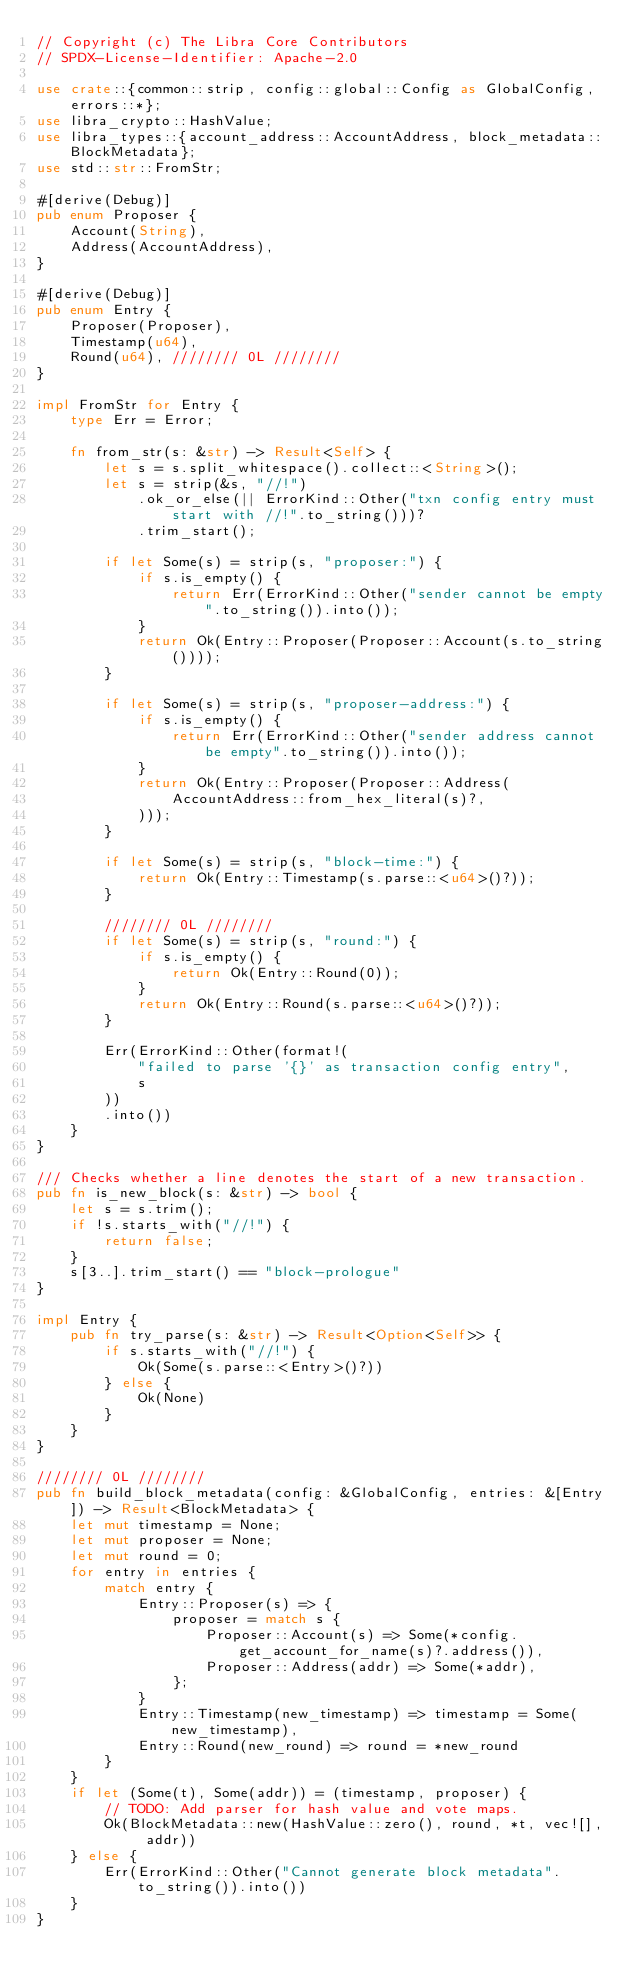Convert code to text. <code><loc_0><loc_0><loc_500><loc_500><_Rust_>// Copyright (c) The Libra Core Contributors
// SPDX-License-Identifier: Apache-2.0

use crate::{common::strip, config::global::Config as GlobalConfig, errors::*};
use libra_crypto::HashValue;
use libra_types::{account_address::AccountAddress, block_metadata::BlockMetadata};
use std::str::FromStr;

#[derive(Debug)]
pub enum Proposer {
    Account(String),
    Address(AccountAddress),
}

#[derive(Debug)]
pub enum Entry {
    Proposer(Proposer),
    Timestamp(u64),
    Round(u64), //////// 0L ////////
}

impl FromStr for Entry {
    type Err = Error;

    fn from_str(s: &str) -> Result<Self> {
        let s = s.split_whitespace().collect::<String>();
        let s = strip(&s, "//!")
            .ok_or_else(|| ErrorKind::Other("txn config entry must start with //!".to_string()))?
            .trim_start();

        if let Some(s) = strip(s, "proposer:") {
            if s.is_empty() {
                return Err(ErrorKind::Other("sender cannot be empty".to_string()).into());
            }
            return Ok(Entry::Proposer(Proposer::Account(s.to_string())));
        }

        if let Some(s) = strip(s, "proposer-address:") {
            if s.is_empty() {
                return Err(ErrorKind::Other("sender address cannot be empty".to_string()).into());
            }
            return Ok(Entry::Proposer(Proposer::Address(
                AccountAddress::from_hex_literal(s)?,
            )));
        }

        if let Some(s) = strip(s, "block-time:") {
            return Ok(Entry::Timestamp(s.parse::<u64>()?));
        }

        //////// 0L ////////
        if let Some(s) = strip(s, "round:") {
            if s.is_empty() {
                return Ok(Entry::Round(0));
            }
            return Ok(Entry::Round(s.parse::<u64>()?));
        }

        Err(ErrorKind::Other(format!(
            "failed to parse '{}' as transaction config entry",
            s
        ))
        .into())
    }
}

/// Checks whether a line denotes the start of a new transaction.
pub fn is_new_block(s: &str) -> bool {
    let s = s.trim();
    if !s.starts_with("//!") {
        return false;
    }
    s[3..].trim_start() == "block-prologue"
}

impl Entry {
    pub fn try_parse(s: &str) -> Result<Option<Self>> {
        if s.starts_with("//!") {
            Ok(Some(s.parse::<Entry>()?))
        } else {
            Ok(None)
        }
    }
}

//////// 0L ////////
pub fn build_block_metadata(config: &GlobalConfig, entries: &[Entry]) -> Result<BlockMetadata> {
    let mut timestamp = None;
    let mut proposer = None;
    let mut round = 0;
    for entry in entries {
        match entry {
            Entry::Proposer(s) => {
                proposer = match s {
                    Proposer::Account(s) => Some(*config.get_account_for_name(s)?.address()),
                    Proposer::Address(addr) => Some(*addr),
                };
            }
            Entry::Timestamp(new_timestamp) => timestamp = Some(new_timestamp),
            Entry::Round(new_round) => round = *new_round
        }
    }
    if let (Some(t), Some(addr)) = (timestamp, proposer) {
        // TODO: Add parser for hash value and vote maps.
        Ok(BlockMetadata::new(HashValue::zero(), round, *t, vec![], addr))
    } else {
        Err(ErrorKind::Other("Cannot generate block metadata".to_string()).into())
    }
}
</code> 